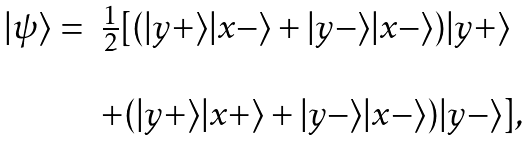<formula> <loc_0><loc_0><loc_500><loc_500>\begin{array} { r l } | \psi \rangle = & \frac { 1 } { 2 } [ ( | y + \rangle | x - \rangle + | y - \rangle | x - \rangle ) | y + \rangle \\ & \\ & + ( | y + \rangle | x + \rangle + | y - \rangle | x - \rangle ) | y - \rangle ] , \end{array}</formula> 